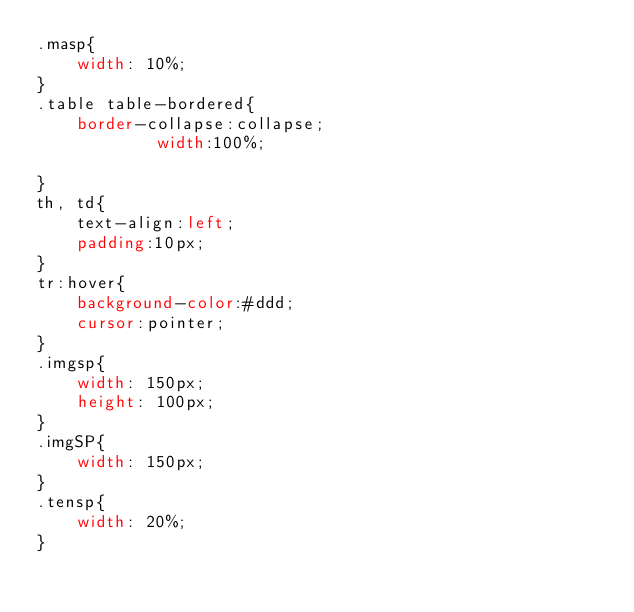<code> <loc_0><loc_0><loc_500><loc_500><_CSS_>.masp{
    width: 10%;
}
.table table-bordered{
    border-collapse:collapse;
            width:100%;
            
}
th, td{
    text-align:left;
    padding:10px;
}
tr:hover{
    background-color:#ddd;
    cursor:pointer;
}
.imgsp{
    width: 150px;
    height: 100px;
}
.imgSP{
    width: 150px;
}
.tensp{
    width: 20%;
}</code> 